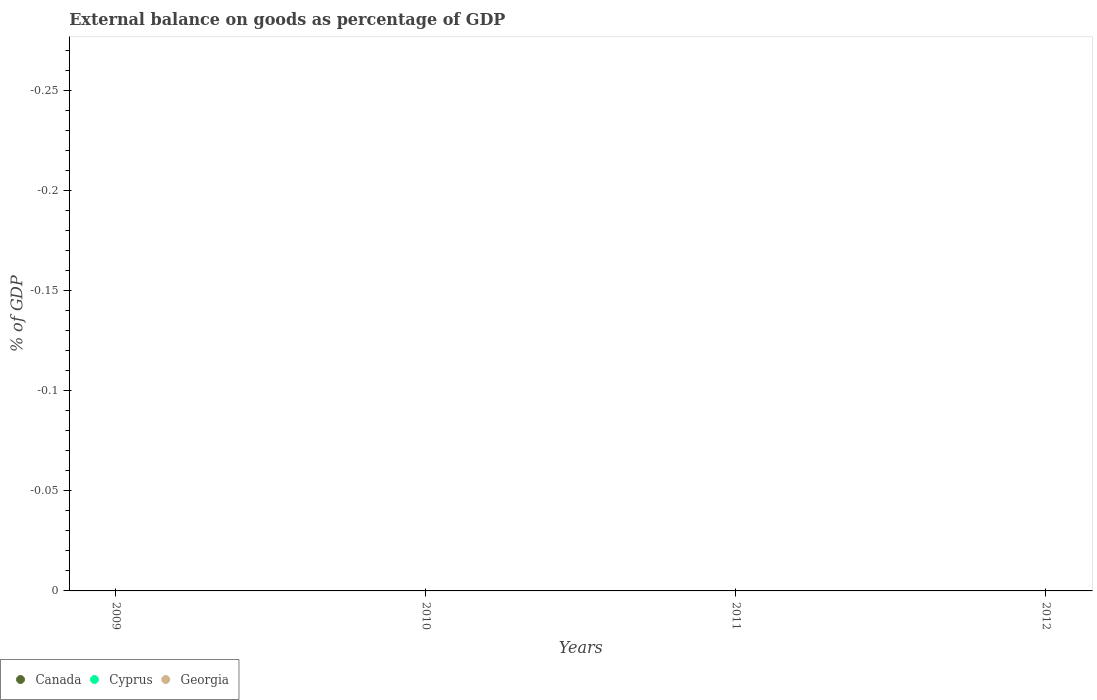What is the external balance on goods as percentage of GDP in Cyprus in 2009?
Give a very brief answer. 0. In how many years, is the external balance on goods as percentage of GDP in Cyprus greater than -0.23 %?
Provide a succinct answer. 0. Is it the case that in every year, the sum of the external balance on goods as percentage of GDP in Georgia and external balance on goods as percentage of GDP in Canada  is greater than the external balance on goods as percentage of GDP in Cyprus?
Make the answer very short. No. Does the external balance on goods as percentage of GDP in Georgia monotonically increase over the years?
Give a very brief answer. No. Is the external balance on goods as percentage of GDP in Georgia strictly greater than the external balance on goods as percentage of GDP in Canada over the years?
Make the answer very short. No. How many years are there in the graph?
Your response must be concise. 4. What is the difference between two consecutive major ticks on the Y-axis?
Make the answer very short. 0.05. Does the graph contain any zero values?
Ensure brevity in your answer.  Yes. Where does the legend appear in the graph?
Make the answer very short. Bottom left. How are the legend labels stacked?
Your answer should be compact. Horizontal. What is the title of the graph?
Your answer should be very brief. External balance on goods as percentage of GDP. What is the label or title of the Y-axis?
Your answer should be very brief. % of GDP. What is the % of GDP of Canada in 2009?
Your answer should be very brief. 0. What is the % of GDP in Cyprus in 2009?
Make the answer very short. 0. What is the % of GDP in Cyprus in 2011?
Ensure brevity in your answer.  0. What is the % of GDP in Georgia in 2011?
Offer a very short reply. 0. What is the % of GDP of Canada in 2012?
Your response must be concise. 0. What is the % of GDP of Cyprus in 2012?
Make the answer very short. 0. What is the % of GDP in Georgia in 2012?
Your answer should be very brief. 0. What is the average % of GDP in Cyprus per year?
Offer a very short reply. 0. What is the average % of GDP in Georgia per year?
Ensure brevity in your answer.  0. 